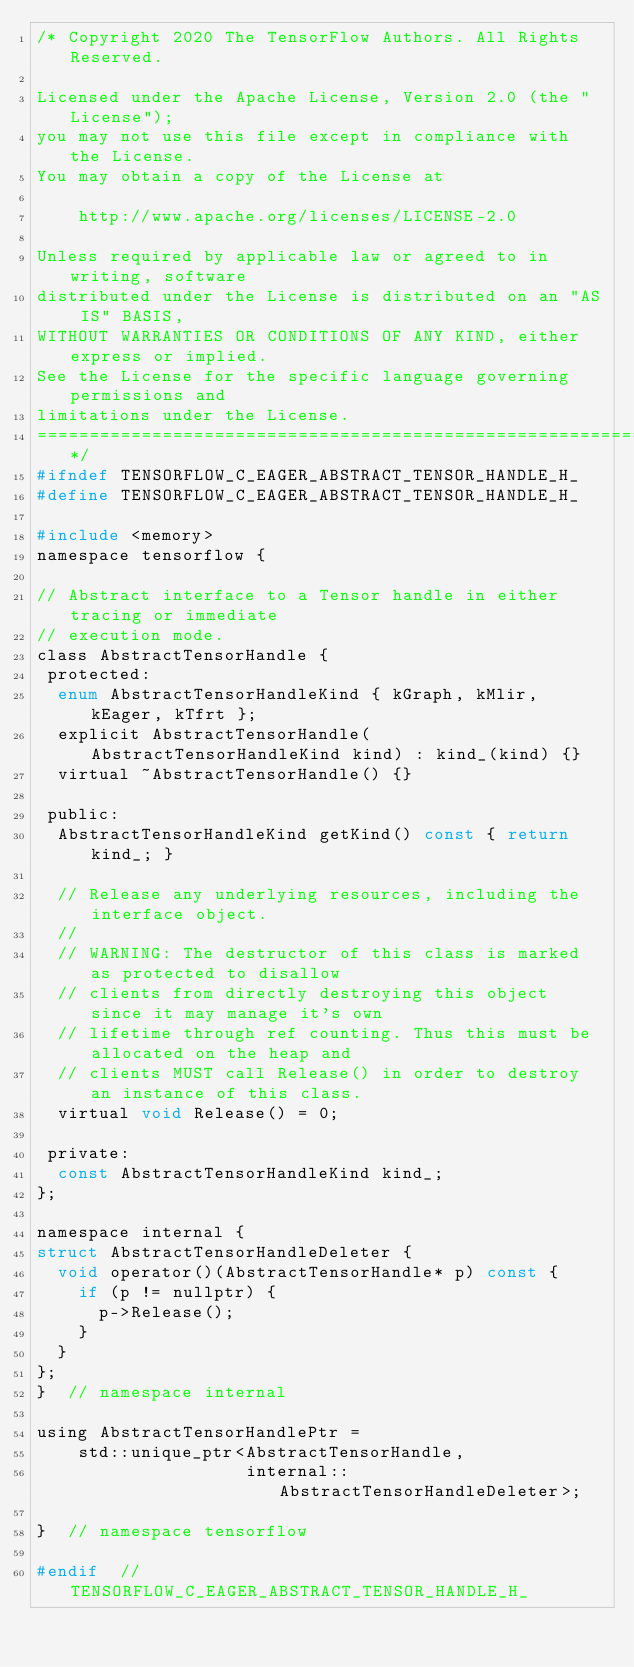Convert code to text. <code><loc_0><loc_0><loc_500><loc_500><_C_>/* Copyright 2020 The TensorFlow Authors. All Rights Reserved.

Licensed under the Apache License, Version 2.0 (the "License");
you may not use this file except in compliance with the License.
You may obtain a copy of the License at

    http://www.apache.org/licenses/LICENSE-2.0

Unless required by applicable law or agreed to in writing, software
distributed under the License is distributed on an "AS IS" BASIS,
WITHOUT WARRANTIES OR CONDITIONS OF ANY KIND, either express or implied.
See the License for the specific language governing permissions and
limitations under the License.
==============================================================================*/
#ifndef TENSORFLOW_C_EAGER_ABSTRACT_TENSOR_HANDLE_H_
#define TENSORFLOW_C_EAGER_ABSTRACT_TENSOR_HANDLE_H_

#include <memory>
namespace tensorflow {

// Abstract interface to a Tensor handle in either tracing or immediate
// execution mode.
class AbstractTensorHandle {
 protected:
  enum AbstractTensorHandleKind { kGraph, kMlir, kEager, kTfrt };
  explicit AbstractTensorHandle(AbstractTensorHandleKind kind) : kind_(kind) {}
  virtual ~AbstractTensorHandle() {}

 public:
  AbstractTensorHandleKind getKind() const { return kind_; }

  // Release any underlying resources, including the interface object.
  //
  // WARNING: The destructor of this class is marked as protected to disallow
  // clients from directly destroying this object since it may manage it's own
  // lifetime through ref counting. Thus this must be allocated on the heap and
  // clients MUST call Release() in order to destroy an instance of this class.
  virtual void Release() = 0;

 private:
  const AbstractTensorHandleKind kind_;
};

namespace internal {
struct AbstractTensorHandleDeleter {
  void operator()(AbstractTensorHandle* p) const {
    if (p != nullptr) {
      p->Release();
    }
  }
};
}  // namespace internal

using AbstractTensorHandlePtr =
    std::unique_ptr<AbstractTensorHandle,
                    internal::AbstractTensorHandleDeleter>;

}  // namespace tensorflow

#endif  // TENSORFLOW_C_EAGER_ABSTRACT_TENSOR_HANDLE_H_
</code> 